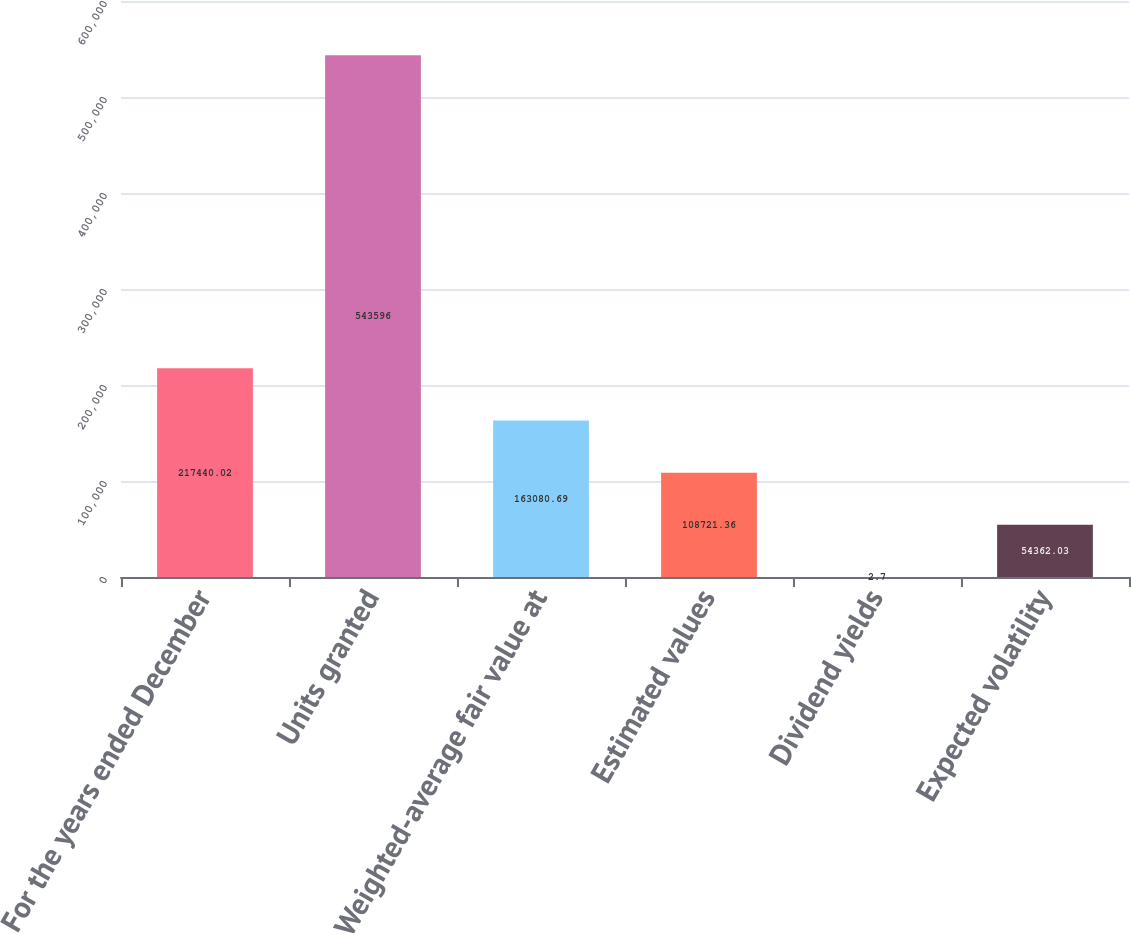Convert chart to OTSL. <chart><loc_0><loc_0><loc_500><loc_500><bar_chart><fcel>For the years ended December<fcel>Units granted<fcel>Weighted-average fair value at<fcel>Estimated values<fcel>Dividend yields<fcel>Expected volatility<nl><fcel>217440<fcel>543596<fcel>163081<fcel>108721<fcel>2.7<fcel>54362<nl></chart> 